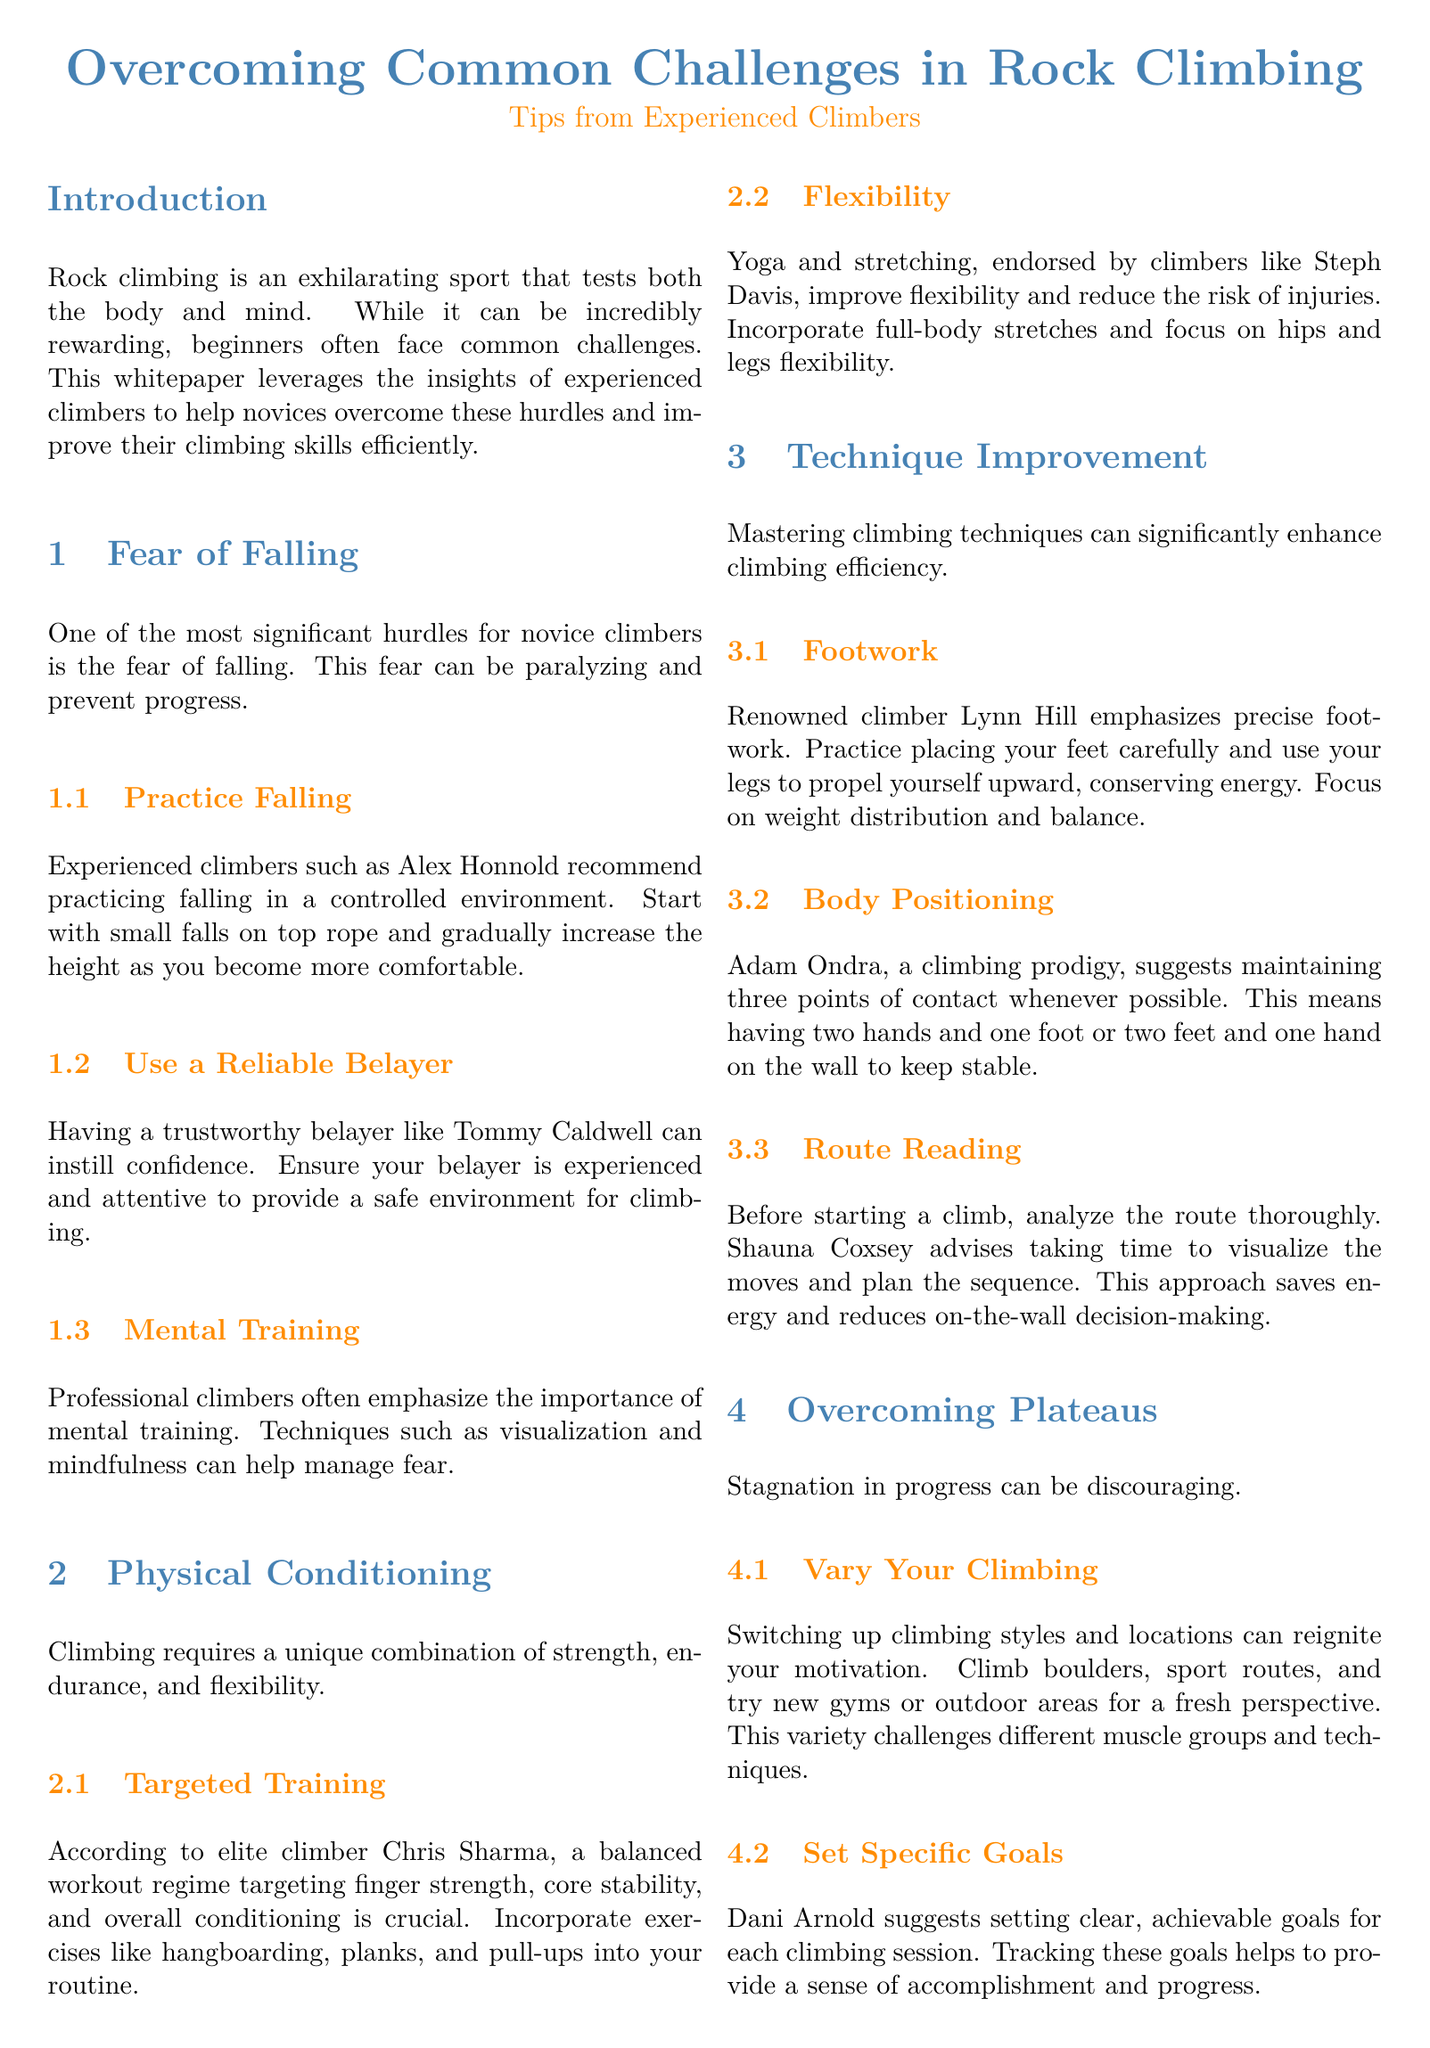What is the main topic of the whitepaper? The main topic is about overcoming challenges in rock climbing, as stated in the title.
Answer: Overcoming Common Challenges in Rock Climbing Who is recommended for practicing falling? The whitepaper references experienced climber Alex Honnold for practicing falling.
Answer: Alex Honnold What should a climber focus on according to Chris Sharma? Chris Sharma advises climbers to target finger strength, core stability, and overall conditioning.
Answer: Targeted training Which yoga-related practice is mentioned for flexibility? The document suggests yoga and stretching for improving flexibility.
Answer: Yoga and stretching What technique does Lynn Hill emphasize? Lynn Hill emphasizes the importance of precise footwork during climbing.
Answer: Precise footwork Who suggests setting clear, achievable goals for climbing sessions? Dani Arnold recommends setting clear, achievable goals to track progress in climbing sessions.
Answer: Dani Arnold What is the purpose of practicing route reading according to Shauna Coxsey? Shauna Coxsey advises analyzing routes to visualize moves and save energy.
Answer: Save energy What is one way to overcome stagnation in climbing progress? The document suggests varying climbing styles and locations to reignite motivation.
Answer: Vary your climbing How is mental training described in the context of managing fear? Mental training involves techniques such as visualization and mindfulness.
Answer: Visualization and mindfulness 